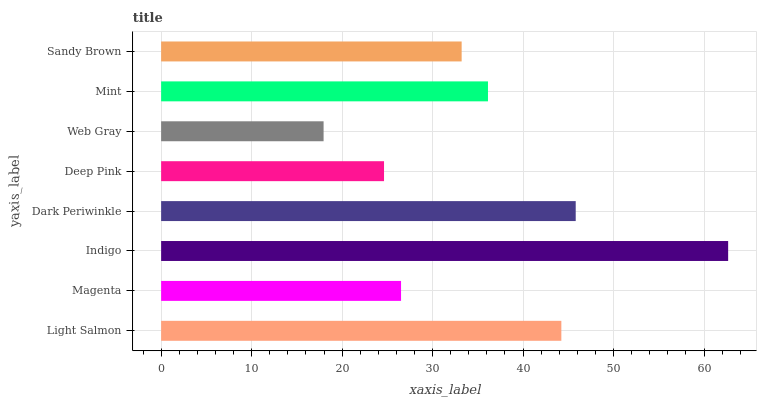Is Web Gray the minimum?
Answer yes or no. Yes. Is Indigo the maximum?
Answer yes or no. Yes. Is Magenta the minimum?
Answer yes or no. No. Is Magenta the maximum?
Answer yes or no. No. Is Light Salmon greater than Magenta?
Answer yes or no. Yes. Is Magenta less than Light Salmon?
Answer yes or no. Yes. Is Magenta greater than Light Salmon?
Answer yes or no. No. Is Light Salmon less than Magenta?
Answer yes or no. No. Is Mint the high median?
Answer yes or no. Yes. Is Sandy Brown the low median?
Answer yes or no. Yes. Is Deep Pink the high median?
Answer yes or no. No. Is Web Gray the low median?
Answer yes or no. No. 